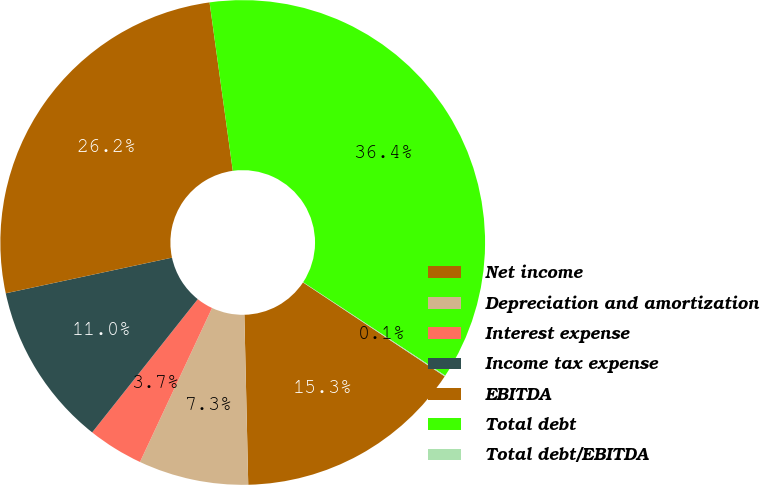Convert chart. <chart><loc_0><loc_0><loc_500><loc_500><pie_chart><fcel>Net income<fcel>Depreciation and amortization<fcel>Interest expense<fcel>Income tax expense<fcel>EBITDA<fcel>Total debt<fcel>Total debt/EBITDA<nl><fcel>15.32%<fcel>7.33%<fcel>3.7%<fcel>10.97%<fcel>26.18%<fcel>36.44%<fcel>0.06%<nl></chart> 